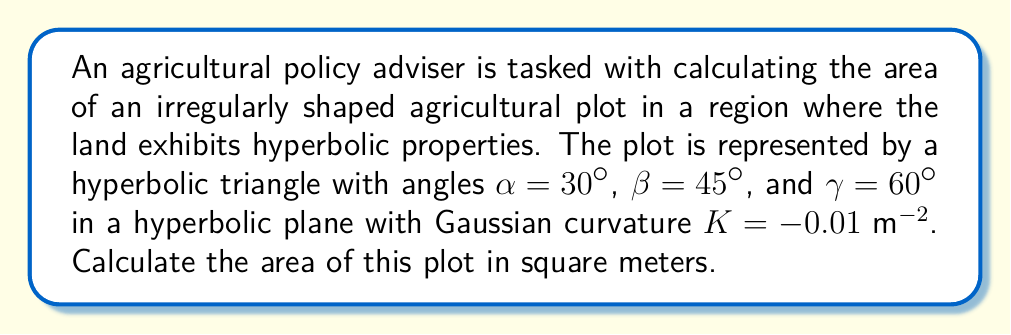Teach me how to tackle this problem. To calculate the area of the hyperbolic triangle, we'll use the following steps:

1) In hyperbolic geometry, the area of a triangle is given by the Gauss-Bonnet formula:

   $$A = \frac{\alpha + \beta + \gamma - \pi}{-K}$$

   where $A$ is the area, $\alpha$, $\beta$, and $\gamma$ are the angles of the triangle in radians, and $K$ is the Gaussian curvature.

2) Convert the given angles from degrees to radians:
   $\alpha = 30° = \frac{\pi}{6}$ rad
   $\beta = 45° = \frac{\pi}{4}$ rad
   $\gamma = 60° = \frac{\pi}{3}$ rad

3) Substitute these values into the formula:

   $$A = \frac{(\frac{\pi}{6} + \frac{\pi}{4} + \frac{\pi}{3}) - \pi}{-(-0.01 \text{ m}^{-2})}$$

4) Simplify the numerator:

   $$A = \frac{(\frac{\pi}{6} + \frac{\pi}{4} + \frac{\pi}{3}) - \pi}{0.01 \text{ m}^{-2}}$$
   $$= \frac{(\frac{2\pi + 3\pi + 4\pi}{12}) - \pi}{0.01 \text{ m}^{-2}}$$
   $$= \frac{(\frac{9\pi}{12}) - \pi}{0.01 \text{ m}^{-2}}$$
   $$= \frac{(\frac{3\pi}{4}) - \pi}{0.01 \text{ m}^{-2}}$$
   $$= \frac{-\frac{\pi}{4}}{0.01 \text{ m}^{-2}}$$

5) Calculate the final result:

   $$A = \frac{-\frac{\pi}{4}}{0.01 \text{ m}^{-2}} = -\frac{\pi}{0.04} \text{ m}^2 \approx 78.54 \text{ m}^2$$
Answer: $78.54 \text{ m}^2$ 